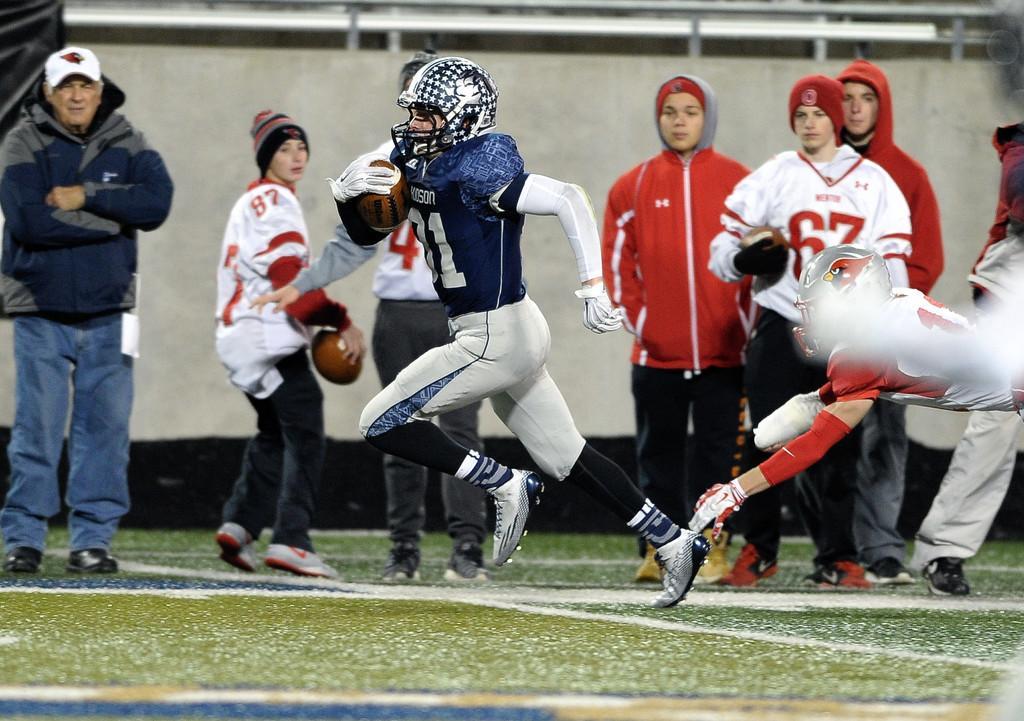Describe this image in one or two sentences. The man in the middle of the picture wearing blue T-shirt and helmet is holding a football in his hand. He is running. Behind him, we see a man in red T-shirt is running behind him. Beside them, we see people are standing and they are watching them. The girl in white T-shirt is holding a football in her hand. In the background, we see a wall and a black color sheet. This picture is clicked in the football field. 